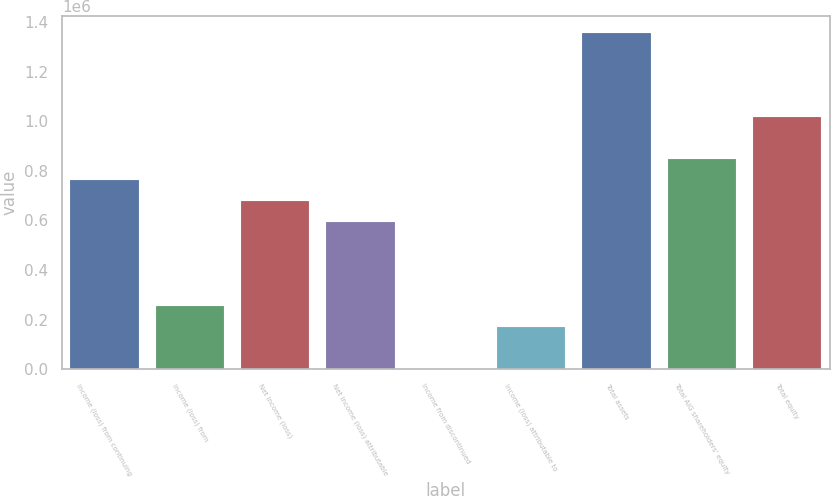Convert chart to OTSL. <chart><loc_0><loc_0><loc_500><loc_500><bar_chart><fcel>Income (loss) from continuing<fcel>Income (loss) from<fcel>Net income (loss)<fcel>Net income (loss) attributable<fcel>Income from discontinued<fcel>Income (loss) attributable to<fcel>Total assets<fcel>Total AIG shareholders' equity<fcel>Total equity<nl><fcel>762828<fcel>254283<fcel>678070<fcel>593313<fcel>11.22<fcel>169526<fcel>1.35613e+06<fcel>847585<fcel>1.0171e+06<nl></chart> 